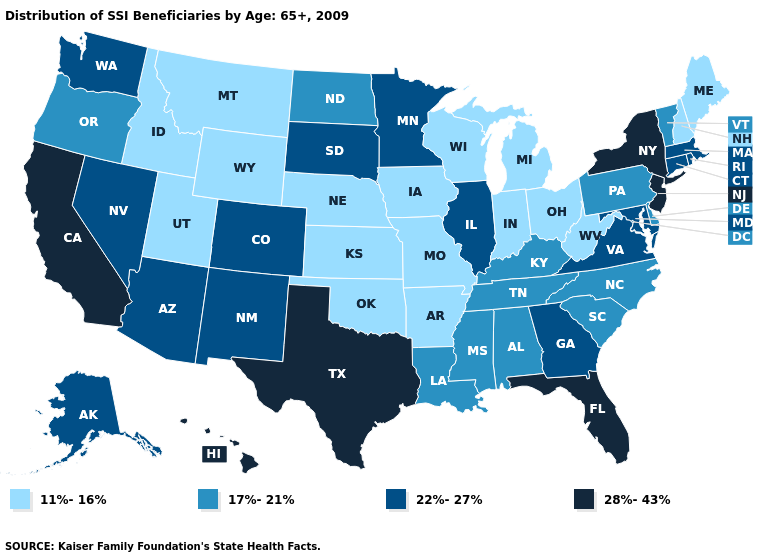Which states hav the highest value in the MidWest?
Short answer required. Illinois, Minnesota, South Dakota. Name the states that have a value in the range 28%-43%?
Quick response, please. California, Florida, Hawaii, New Jersey, New York, Texas. Does West Virginia have the highest value in the USA?
Keep it brief. No. What is the lowest value in states that border Indiana?
Concise answer only. 11%-16%. What is the lowest value in the West?
Answer briefly. 11%-16%. What is the value of Wisconsin?
Concise answer only. 11%-16%. Name the states that have a value in the range 17%-21%?
Be succinct. Alabama, Delaware, Kentucky, Louisiana, Mississippi, North Carolina, North Dakota, Oregon, Pennsylvania, South Carolina, Tennessee, Vermont. Name the states that have a value in the range 28%-43%?
Be succinct. California, Florida, Hawaii, New Jersey, New York, Texas. Does Nevada have a higher value than Indiana?
Give a very brief answer. Yes. Does South Carolina have a lower value than Illinois?
Concise answer only. Yes. Name the states that have a value in the range 22%-27%?
Give a very brief answer. Alaska, Arizona, Colorado, Connecticut, Georgia, Illinois, Maryland, Massachusetts, Minnesota, Nevada, New Mexico, Rhode Island, South Dakota, Virginia, Washington. What is the value of Maryland?
Concise answer only. 22%-27%. Does Illinois have the highest value in the MidWest?
Write a very short answer. Yes. Does the map have missing data?
Answer briefly. No. What is the value of Delaware?
Concise answer only. 17%-21%. 